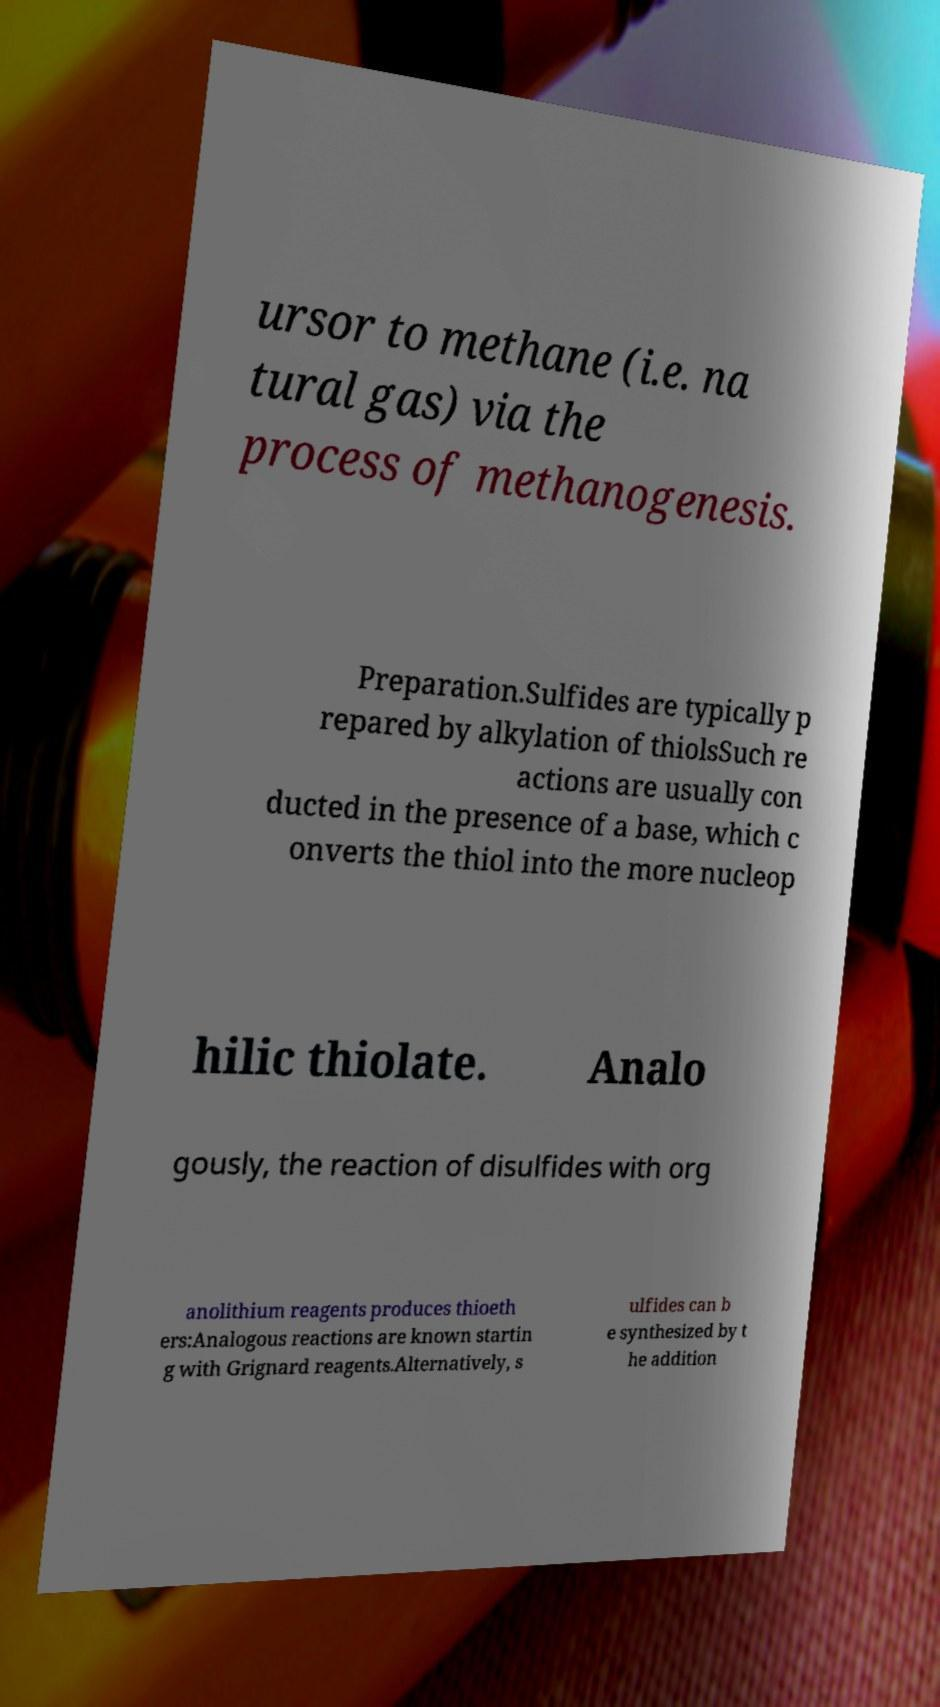Could you assist in decoding the text presented in this image and type it out clearly? ursor to methane (i.e. na tural gas) via the process of methanogenesis. Preparation.Sulfides are typically p repared by alkylation of thiolsSuch re actions are usually con ducted in the presence of a base, which c onverts the thiol into the more nucleop hilic thiolate. Analo gously, the reaction of disulfides with org anolithium reagents produces thioeth ers:Analogous reactions are known startin g with Grignard reagents.Alternatively, s ulfides can b e synthesized by t he addition 